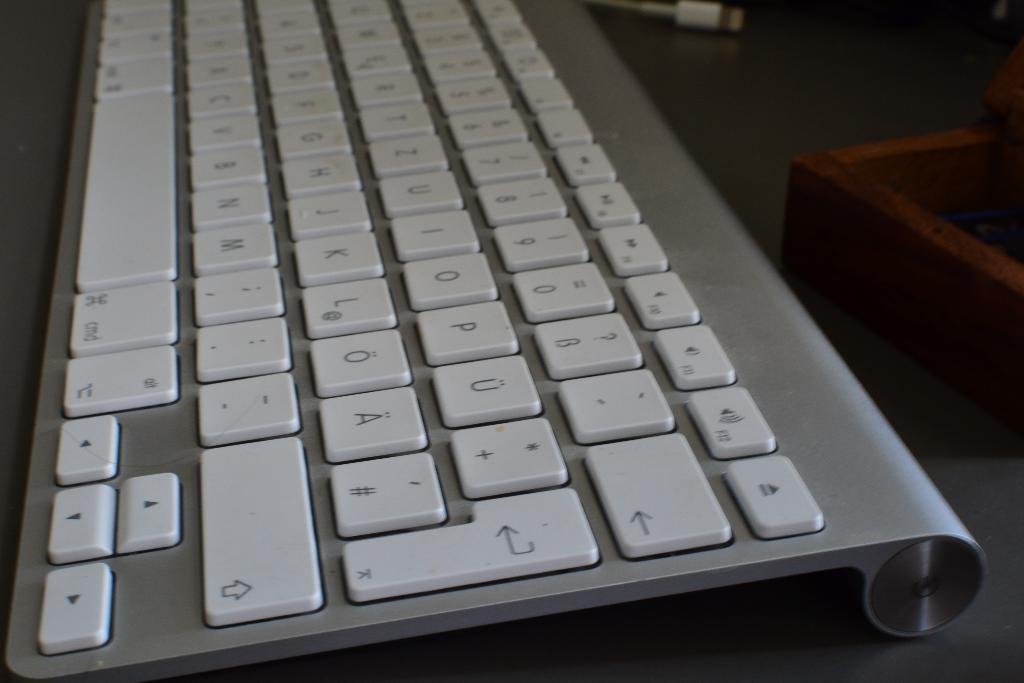<image>
Present a compact description of the photo's key features. A chrome and white keyboard that uses the English alphabet. 